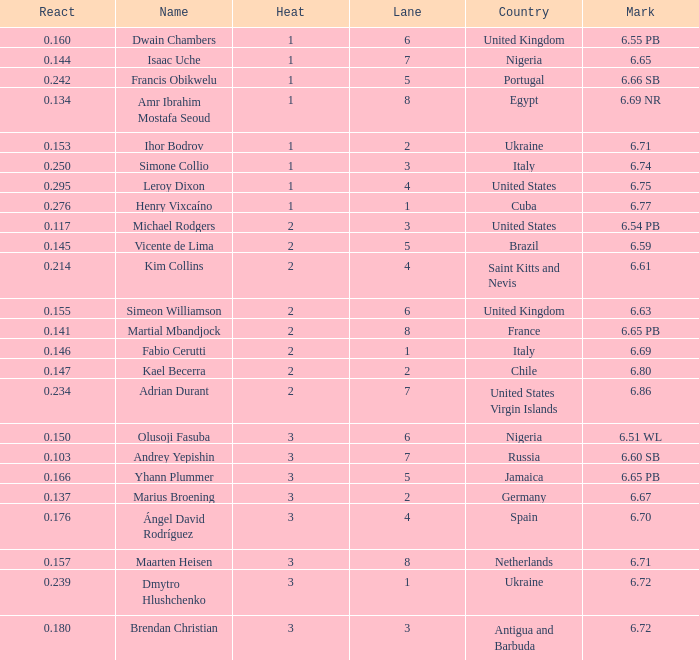What is Heat, when Mark is 6.69? 2.0. 